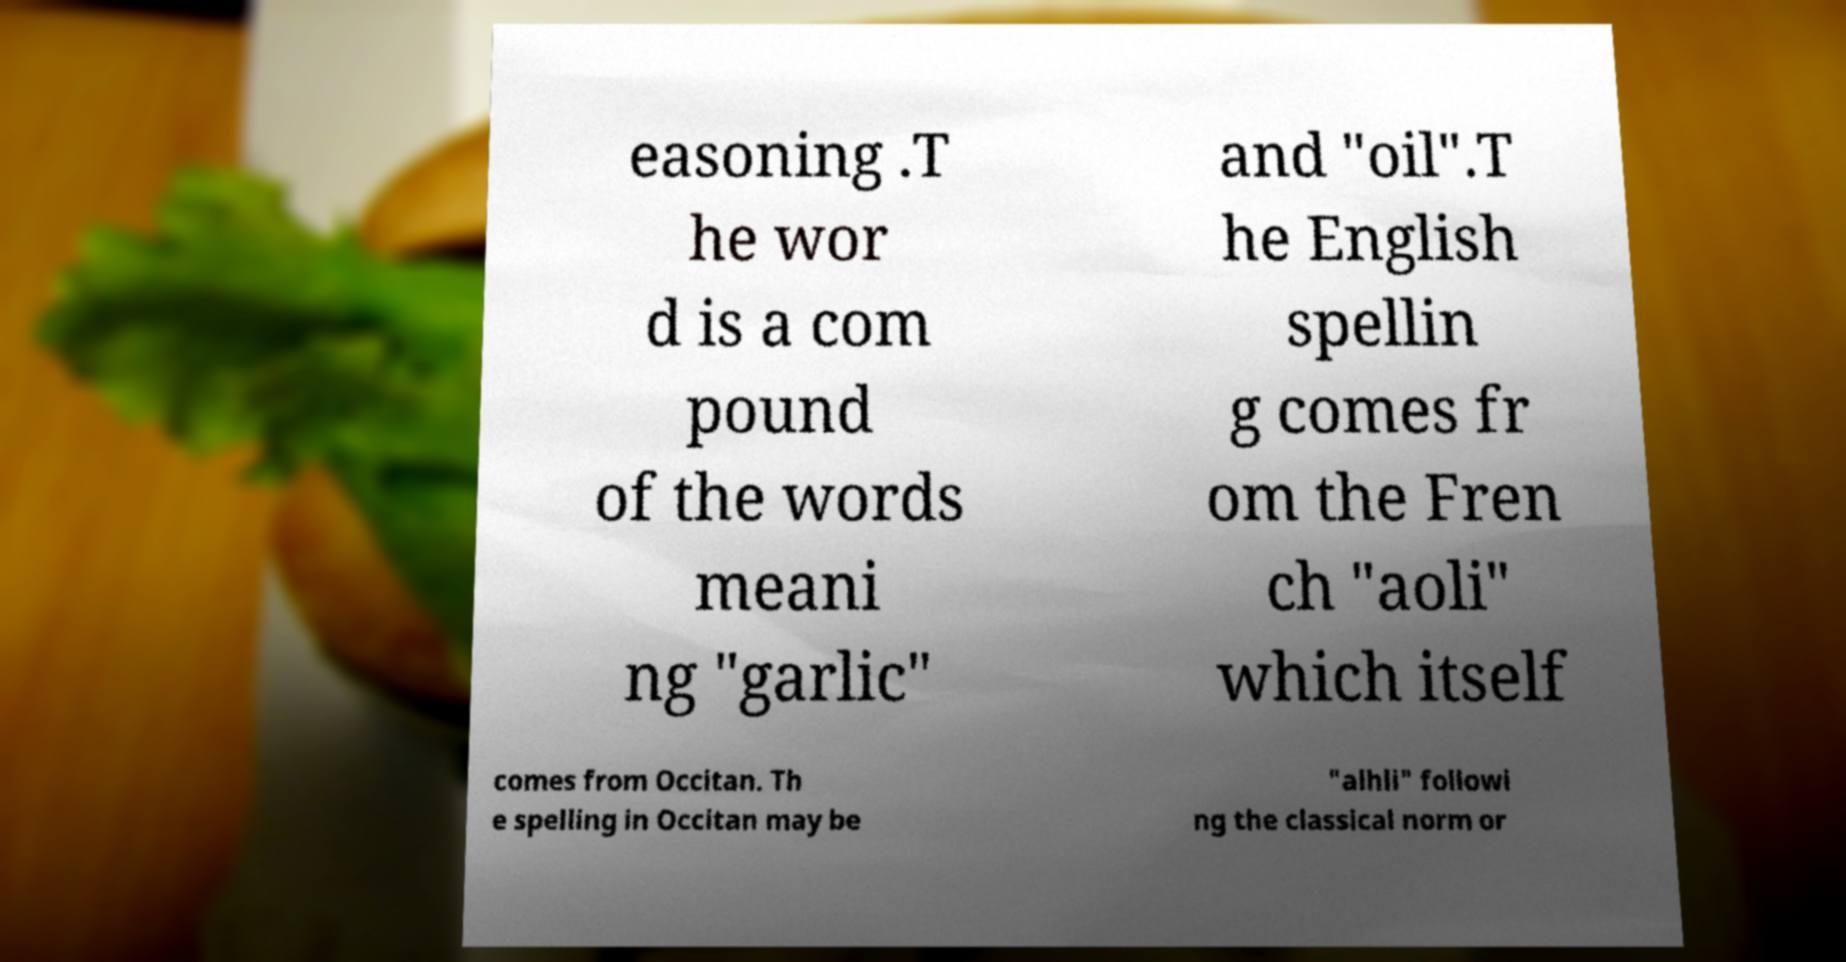Could you extract and type out the text from this image? easoning .T he wor d is a com pound of the words meani ng "garlic" and "oil".T he English spellin g comes fr om the Fren ch "aoli" which itself comes from Occitan. Th e spelling in Occitan may be "alhli" followi ng the classical norm or 